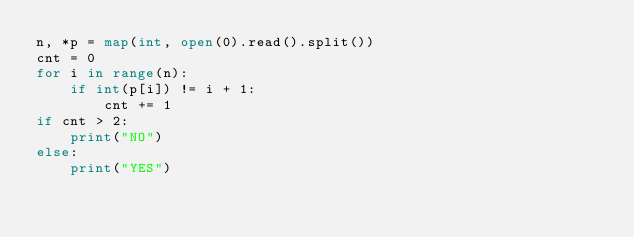<code> <loc_0><loc_0><loc_500><loc_500><_Python_>n, *p = map(int, open(0).read().split())
cnt = 0
for i in range(n):
    if int(p[i]) != i + 1:
        cnt += 1
if cnt > 2:
    print("NO")
else:
    print("YES")
        </code> 